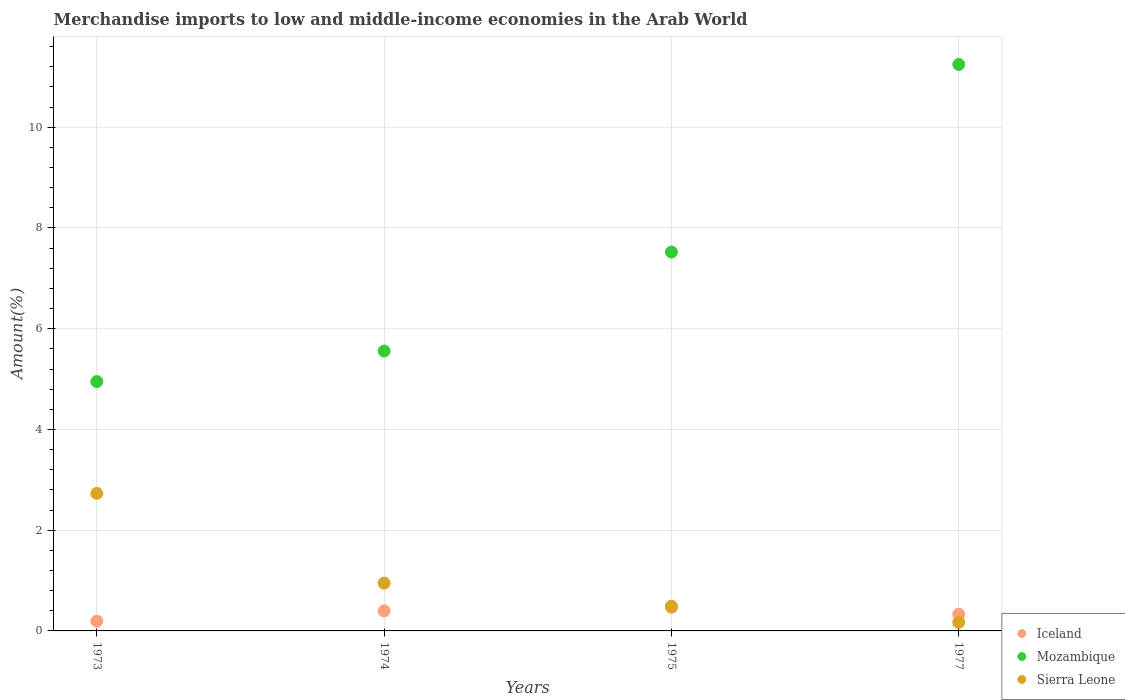Is the number of dotlines equal to the number of legend labels?
Give a very brief answer. Yes. What is the percentage of amount earned from merchandise imports in Iceland in 1973?
Your answer should be very brief. 0.19. Across all years, what is the maximum percentage of amount earned from merchandise imports in Mozambique?
Give a very brief answer. 11.25. Across all years, what is the minimum percentage of amount earned from merchandise imports in Mozambique?
Your answer should be very brief. 4.95. In which year was the percentage of amount earned from merchandise imports in Mozambique maximum?
Your answer should be very brief. 1977. What is the total percentage of amount earned from merchandise imports in Iceland in the graph?
Offer a very short reply. 1.39. What is the difference between the percentage of amount earned from merchandise imports in Mozambique in 1973 and that in 1977?
Provide a succinct answer. -6.3. What is the difference between the percentage of amount earned from merchandise imports in Mozambique in 1975 and the percentage of amount earned from merchandise imports in Sierra Leone in 1977?
Give a very brief answer. 7.35. What is the average percentage of amount earned from merchandise imports in Sierra Leone per year?
Ensure brevity in your answer.  1.09. In the year 1973, what is the difference between the percentage of amount earned from merchandise imports in Iceland and percentage of amount earned from merchandise imports in Sierra Leone?
Give a very brief answer. -2.54. What is the ratio of the percentage of amount earned from merchandise imports in Sierra Leone in 1974 to that in 1975?
Provide a succinct answer. 1.93. Is the difference between the percentage of amount earned from merchandise imports in Iceland in 1974 and 1977 greater than the difference between the percentage of amount earned from merchandise imports in Sierra Leone in 1974 and 1977?
Keep it short and to the point. No. What is the difference between the highest and the second highest percentage of amount earned from merchandise imports in Mozambique?
Provide a short and direct response. 3.72. What is the difference between the highest and the lowest percentage of amount earned from merchandise imports in Iceland?
Your answer should be very brief. 0.27. In how many years, is the percentage of amount earned from merchandise imports in Sierra Leone greater than the average percentage of amount earned from merchandise imports in Sierra Leone taken over all years?
Offer a terse response. 1. Is it the case that in every year, the sum of the percentage of amount earned from merchandise imports in Sierra Leone and percentage of amount earned from merchandise imports in Iceland  is greater than the percentage of amount earned from merchandise imports in Mozambique?
Your answer should be very brief. No. Does the percentage of amount earned from merchandise imports in Iceland monotonically increase over the years?
Offer a terse response. No. Is the percentage of amount earned from merchandise imports in Mozambique strictly greater than the percentage of amount earned from merchandise imports in Sierra Leone over the years?
Ensure brevity in your answer.  Yes. What is the difference between two consecutive major ticks on the Y-axis?
Offer a terse response. 2. Are the values on the major ticks of Y-axis written in scientific E-notation?
Provide a short and direct response. No. Does the graph contain grids?
Provide a succinct answer. Yes. How are the legend labels stacked?
Your response must be concise. Vertical. What is the title of the graph?
Provide a short and direct response. Merchandise imports to low and middle-income economies in the Arab World. What is the label or title of the Y-axis?
Provide a succinct answer. Amount(%). What is the Amount(%) of Iceland in 1973?
Offer a very short reply. 0.19. What is the Amount(%) of Mozambique in 1973?
Provide a short and direct response. 4.95. What is the Amount(%) of Sierra Leone in 1973?
Offer a terse response. 2.73. What is the Amount(%) of Iceland in 1974?
Provide a short and direct response. 0.4. What is the Amount(%) in Mozambique in 1974?
Give a very brief answer. 5.56. What is the Amount(%) in Sierra Leone in 1974?
Give a very brief answer. 0.95. What is the Amount(%) in Iceland in 1975?
Your response must be concise. 0.47. What is the Amount(%) of Mozambique in 1975?
Ensure brevity in your answer.  7.52. What is the Amount(%) in Sierra Leone in 1975?
Your response must be concise. 0.49. What is the Amount(%) in Iceland in 1977?
Offer a terse response. 0.33. What is the Amount(%) in Mozambique in 1977?
Your response must be concise. 11.25. What is the Amount(%) of Sierra Leone in 1977?
Keep it short and to the point. 0.17. Across all years, what is the maximum Amount(%) of Iceland?
Provide a short and direct response. 0.47. Across all years, what is the maximum Amount(%) in Mozambique?
Offer a very short reply. 11.25. Across all years, what is the maximum Amount(%) in Sierra Leone?
Your answer should be compact. 2.73. Across all years, what is the minimum Amount(%) of Iceland?
Offer a very short reply. 0.19. Across all years, what is the minimum Amount(%) in Mozambique?
Keep it short and to the point. 4.95. Across all years, what is the minimum Amount(%) of Sierra Leone?
Your response must be concise. 0.17. What is the total Amount(%) of Iceland in the graph?
Make the answer very short. 1.39. What is the total Amount(%) of Mozambique in the graph?
Your answer should be very brief. 29.28. What is the total Amount(%) of Sierra Leone in the graph?
Your answer should be very brief. 4.34. What is the difference between the Amount(%) of Iceland in 1973 and that in 1974?
Provide a succinct answer. -0.2. What is the difference between the Amount(%) in Mozambique in 1973 and that in 1974?
Give a very brief answer. -0.61. What is the difference between the Amount(%) in Sierra Leone in 1973 and that in 1974?
Your answer should be compact. 1.78. What is the difference between the Amount(%) of Iceland in 1973 and that in 1975?
Make the answer very short. -0.27. What is the difference between the Amount(%) of Mozambique in 1973 and that in 1975?
Your answer should be compact. -2.57. What is the difference between the Amount(%) in Sierra Leone in 1973 and that in 1975?
Your answer should be compact. 2.24. What is the difference between the Amount(%) of Iceland in 1973 and that in 1977?
Provide a succinct answer. -0.14. What is the difference between the Amount(%) in Mozambique in 1973 and that in 1977?
Provide a short and direct response. -6.3. What is the difference between the Amount(%) of Sierra Leone in 1973 and that in 1977?
Make the answer very short. 2.56. What is the difference between the Amount(%) in Iceland in 1974 and that in 1975?
Offer a terse response. -0.07. What is the difference between the Amount(%) in Mozambique in 1974 and that in 1975?
Keep it short and to the point. -1.97. What is the difference between the Amount(%) in Sierra Leone in 1974 and that in 1975?
Make the answer very short. 0.46. What is the difference between the Amount(%) in Iceland in 1974 and that in 1977?
Offer a very short reply. 0.06. What is the difference between the Amount(%) in Mozambique in 1974 and that in 1977?
Give a very brief answer. -5.69. What is the difference between the Amount(%) in Sierra Leone in 1974 and that in 1977?
Your response must be concise. 0.78. What is the difference between the Amount(%) of Iceland in 1975 and that in 1977?
Keep it short and to the point. 0.13. What is the difference between the Amount(%) in Mozambique in 1975 and that in 1977?
Ensure brevity in your answer.  -3.72. What is the difference between the Amount(%) of Sierra Leone in 1975 and that in 1977?
Offer a very short reply. 0.32. What is the difference between the Amount(%) in Iceland in 1973 and the Amount(%) in Mozambique in 1974?
Your response must be concise. -5.36. What is the difference between the Amount(%) in Iceland in 1973 and the Amount(%) in Sierra Leone in 1974?
Offer a terse response. -0.75. What is the difference between the Amount(%) in Mozambique in 1973 and the Amount(%) in Sierra Leone in 1974?
Your answer should be compact. 4. What is the difference between the Amount(%) in Iceland in 1973 and the Amount(%) in Mozambique in 1975?
Offer a terse response. -7.33. What is the difference between the Amount(%) of Iceland in 1973 and the Amount(%) of Sierra Leone in 1975?
Offer a terse response. -0.3. What is the difference between the Amount(%) of Mozambique in 1973 and the Amount(%) of Sierra Leone in 1975?
Your answer should be very brief. 4.46. What is the difference between the Amount(%) of Iceland in 1973 and the Amount(%) of Mozambique in 1977?
Give a very brief answer. -11.05. What is the difference between the Amount(%) in Iceland in 1973 and the Amount(%) in Sierra Leone in 1977?
Your answer should be compact. 0.02. What is the difference between the Amount(%) of Mozambique in 1973 and the Amount(%) of Sierra Leone in 1977?
Keep it short and to the point. 4.78. What is the difference between the Amount(%) in Iceland in 1974 and the Amount(%) in Mozambique in 1975?
Ensure brevity in your answer.  -7.13. What is the difference between the Amount(%) in Iceland in 1974 and the Amount(%) in Sierra Leone in 1975?
Provide a succinct answer. -0.09. What is the difference between the Amount(%) in Mozambique in 1974 and the Amount(%) in Sierra Leone in 1975?
Your answer should be compact. 5.07. What is the difference between the Amount(%) of Iceland in 1974 and the Amount(%) of Mozambique in 1977?
Your answer should be very brief. -10.85. What is the difference between the Amount(%) in Iceland in 1974 and the Amount(%) in Sierra Leone in 1977?
Offer a terse response. 0.23. What is the difference between the Amount(%) in Mozambique in 1974 and the Amount(%) in Sierra Leone in 1977?
Give a very brief answer. 5.38. What is the difference between the Amount(%) in Iceland in 1975 and the Amount(%) in Mozambique in 1977?
Your answer should be very brief. -10.78. What is the difference between the Amount(%) in Iceland in 1975 and the Amount(%) in Sierra Leone in 1977?
Provide a short and direct response. 0.29. What is the difference between the Amount(%) of Mozambique in 1975 and the Amount(%) of Sierra Leone in 1977?
Your answer should be very brief. 7.35. What is the average Amount(%) of Iceland per year?
Offer a very short reply. 0.35. What is the average Amount(%) of Mozambique per year?
Provide a short and direct response. 7.32. What is the average Amount(%) in Sierra Leone per year?
Give a very brief answer. 1.09. In the year 1973, what is the difference between the Amount(%) in Iceland and Amount(%) in Mozambique?
Your response must be concise. -4.76. In the year 1973, what is the difference between the Amount(%) in Iceland and Amount(%) in Sierra Leone?
Provide a short and direct response. -2.54. In the year 1973, what is the difference between the Amount(%) in Mozambique and Amount(%) in Sierra Leone?
Offer a very short reply. 2.22. In the year 1974, what is the difference between the Amount(%) in Iceland and Amount(%) in Mozambique?
Provide a short and direct response. -5.16. In the year 1974, what is the difference between the Amount(%) of Iceland and Amount(%) of Sierra Leone?
Make the answer very short. -0.55. In the year 1974, what is the difference between the Amount(%) of Mozambique and Amount(%) of Sierra Leone?
Give a very brief answer. 4.61. In the year 1975, what is the difference between the Amount(%) in Iceland and Amount(%) in Mozambique?
Offer a terse response. -7.06. In the year 1975, what is the difference between the Amount(%) of Iceland and Amount(%) of Sierra Leone?
Your answer should be compact. -0.03. In the year 1975, what is the difference between the Amount(%) in Mozambique and Amount(%) in Sierra Leone?
Keep it short and to the point. 7.03. In the year 1977, what is the difference between the Amount(%) of Iceland and Amount(%) of Mozambique?
Ensure brevity in your answer.  -10.91. In the year 1977, what is the difference between the Amount(%) in Iceland and Amount(%) in Sierra Leone?
Your answer should be compact. 0.16. In the year 1977, what is the difference between the Amount(%) in Mozambique and Amount(%) in Sierra Leone?
Your answer should be very brief. 11.07. What is the ratio of the Amount(%) of Iceland in 1973 to that in 1974?
Give a very brief answer. 0.49. What is the ratio of the Amount(%) of Mozambique in 1973 to that in 1974?
Make the answer very short. 0.89. What is the ratio of the Amount(%) of Sierra Leone in 1973 to that in 1974?
Your response must be concise. 2.88. What is the ratio of the Amount(%) of Iceland in 1973 to that in 1975?
Offer a terse response. 0.42. What is the ratio of the Amount(%) in Mozambique in 1973 to that in 1975?
Offer a terse response. 0.66. What is the ratio of the Amount(%) of Sierra Leone in 1973 to that in 1975?
Your answer should be very brief. 5.55. What is the ratio of the Amount(%) of Iceland in 1973 to that in 1977?
Your answer should be very brief. 0.58. What is the ratio of the Amount(%) of Mozambique in 1973 to that in 1977?
Provide a short and direct response. 0.44. What is the ratio of the Amount(%) of Sierra Leone in 1973 to that in 1977?
Provide a succinct answer. 15.89. What is the ratio of the Amount(%) in Iceland in 1974 to that in 1975?
Offer a terse response. 0.85. What is the ratio of the Amount(%) in Mozambique in 1974 to that in 1975?
Offer a terse response. 0.74. What is the ratio of the Amount(%) in Sierra Leone in 1974 to that in 1975?
Offer a very short reply. 1.93. What is the ratio of the Amount(%) of Iceland in 1974 to that in 1977?
Keep it short and to the point. 1.19. What is the ratio of the Amount(%) of Mozambique in 1974 to that in 1977?
Your response must be concise. 0.49. What is the ratio of the Amount(%) in Sierra Leone in 1974 to that in 1977?
Your answer should be very brief. 5.52. What is the ratio of the Amount(%) of Iceland in 1975 to that in 1977?
Keep it short and to the point. 1.4. What is the ratio of the Amount(%) of Mozambique in 1975 to that in 1977?
Make the answer very short. 0.67. What is the ratio of the Amount(%) of Sierra Leone in 1975 to that in 1977?
Offer a terse response. 2.86. What is the difference between the highest and the second highest Amount(%) of Iceland?
Give a very brief answer. 0.07. What is the difference between the highest and the second highest Amount(%) of Mozambique?
Provide a succinct answer. 3.72. What is the difference between the highest and the second highest Amount(%) in Sierra Leone?
Provide a short and direct response. 1.78. What is the difference between the highest and the lowest Amount(%) in Iceland?
Your response must be concise. 0.27. What is the difference between the highest and the lowest Amount(%) in Mozambique?
Provide a succinct answer. 6.3. What is the difference between the highest and the lowest Amount(%) in Sierra Leone?
Make the answer very short. 2.56. 